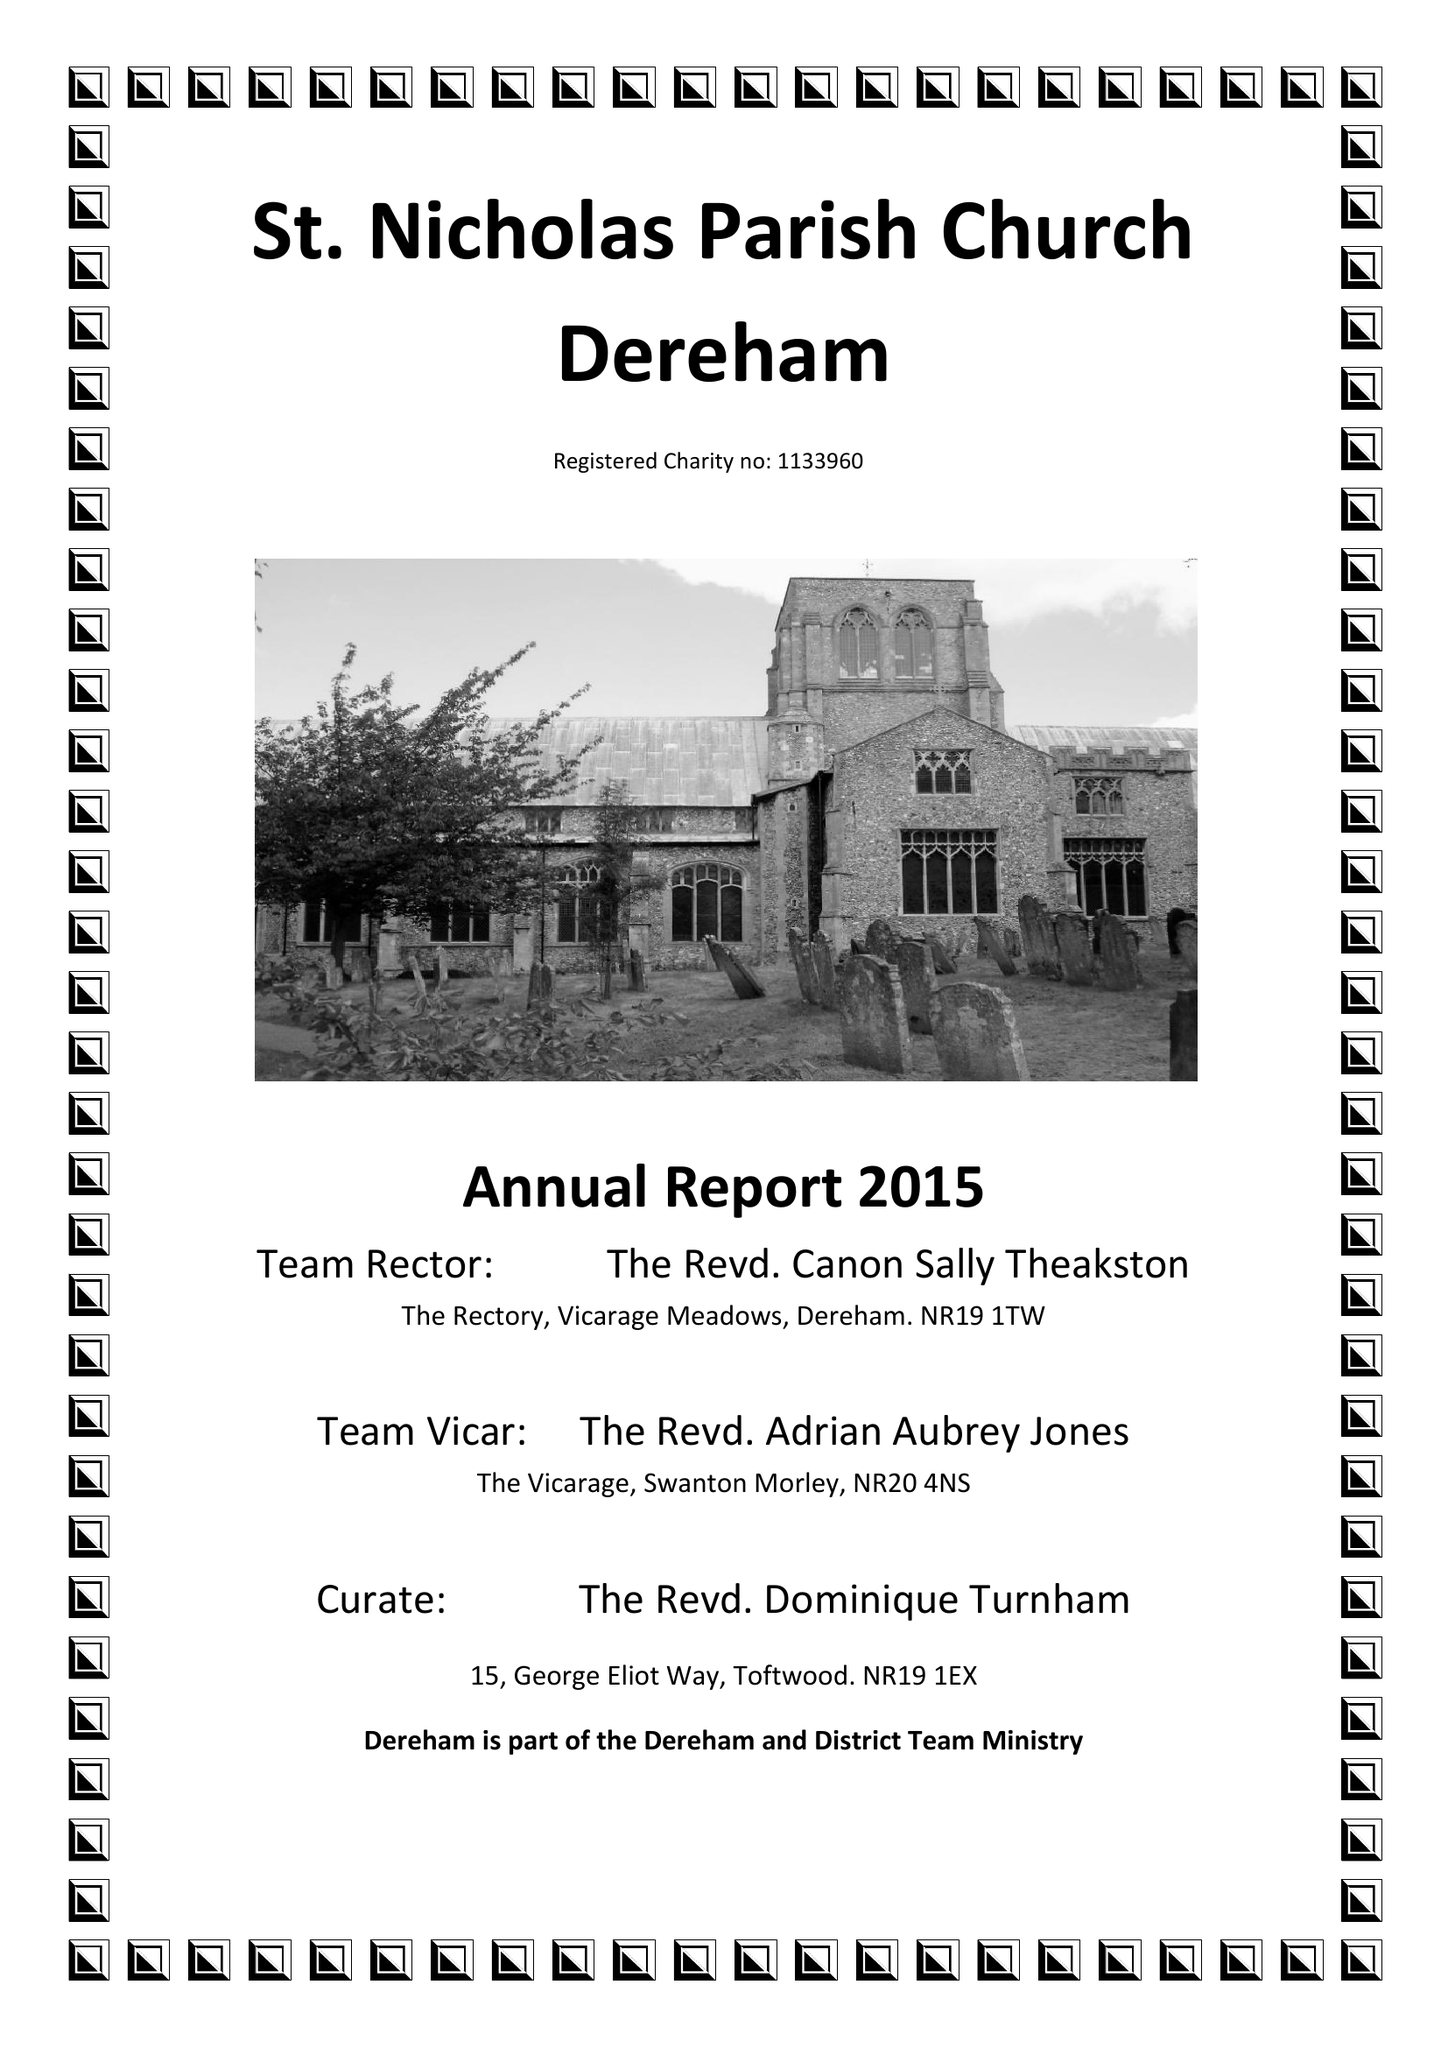What is the value for the address__postcode?
Answer the question using a single word or phrase. NR19 1DN 